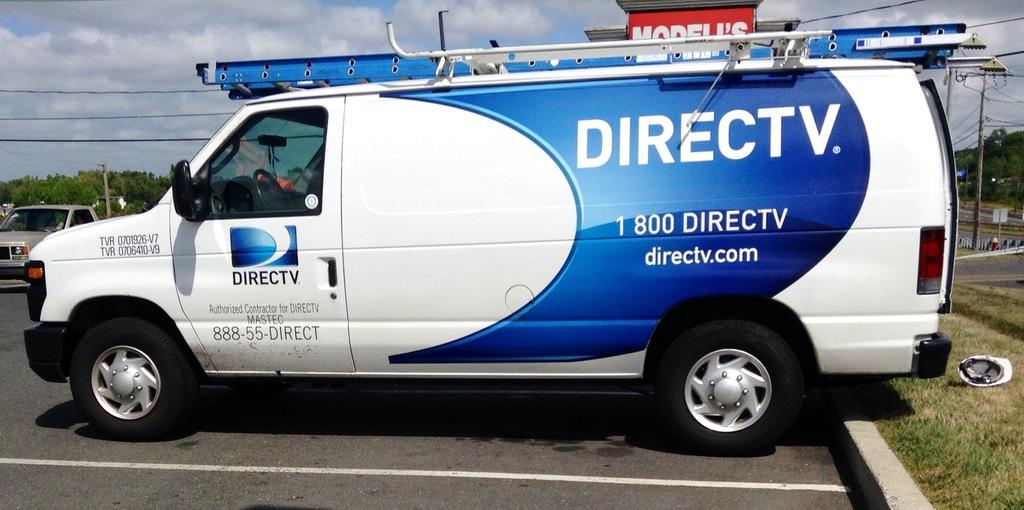What is the word on the sign behind the ladder on top of this van?
Provide a succinct answer. Modell's. Some television car?
Your answer should be very brief. Yes. 